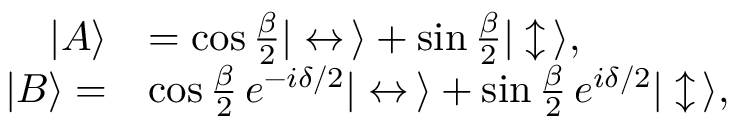Convert formula to latex. <formula><loc_0><loc_0><loc_500><loc_500>\begin{array} { r l } { | A \rangle } & { = \cos { \frac { \beta } { 2 } } | \leftrightarrow \, \rangle + \sin { \frac { \beta } { 2 } } | \updownarrow \, \rangle , } \\ { | B \rangle = } & { \cos { \frac { \beta } { 2 } } \, e ^ { - i \delta / 2 } | \leftrightarrow \, \rangle + \sin { \frac { \beta } { 2 } } \, e ^ { i \delta / 2 } | \updownarrow \, \rangle , } \end{array}</formula> 